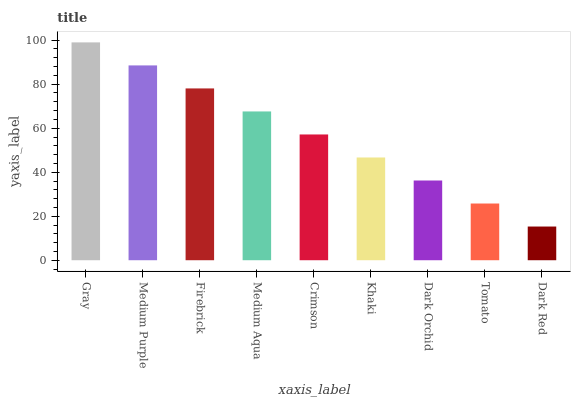Is Dark Red the minimum?
Answer yes or no. Yes. Is Gray the maximum?
Answer yes or no. Yes. Is Medium Purple the minimum?
Answer yes or no. No. Is Medium Purple the maximum?
Answer yes or no. No. Is Gray greater than Medium Purple?
Answer yes or no. Yes. Is Medium Purple less than Gray?
Answer yes or no. Yes. Is Medium Purple greater than Gray?
Answer yes or no. No. Is Gray less than Medium Purple?
Answer yes or no. No. Is Crimson the high median?
Answer yes or no. Yes. Is Crimson the low median?
Answer yes or no. Yes. Is Khaki the high median?
Answer yes or no. No. Is Firebrick the low median?
Answer yes or no. No. 